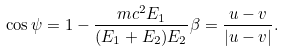<formula> <loc_0><loc_0><loc_500><loc_500>\cos \psi = 1 - \frac { m c ^ { 2 } E _ { 1 } } { ( E _ { 1 } + E _ { 2 } ) E _ { 2 } } \beta = \frac { u - v } { | u - v | } .</formula> 